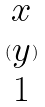<formula> <loc_0><loc_0><loc_500><loc_500>( \begin{matrix} x \\ y \\ 1 \end{matrix} )</formula> 